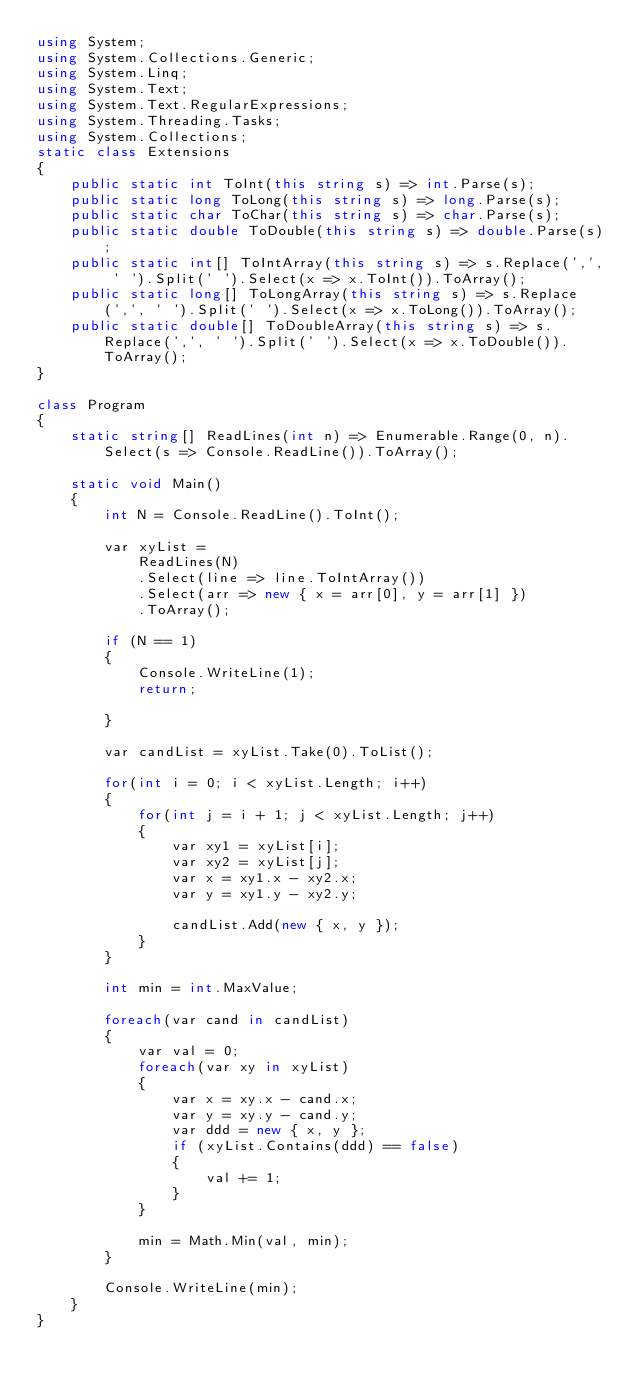Convert code to text. <code><loc_0><loc_0><loc_500><loc_500><_C#_>using System;
using System.Collections.Generic;
using System.Linq;
using System.Text;
using System.Text.RegularExpressions;
using System.Threading.Tasks;
using System.Collections;
static class Extensions
{
    public static int ToInt(this string s) => int.Parse(s);
    public static long ToLong(this string s) => long.Parse(s);
    public static char ToChar(this string s) => char.Parse(s);
    public static double ToDouble(this string s) => double.Parse(s);
    public static int[] ToIntArray(this string s) => s.Replace(',', ' ').Split(' ').Select(x => x.ToInt()).ToArray();
    public static long[] ToLongArray(this string s) => s.Replace(',', ' ').Split(' ').Select(x => x.ToLong()).ToArray();
    public static double[] ToDoubleArray(this string s) => s.Replace(',', ' ').Split(' ').Select(x => x.ToDouble()).ToArray();
}

class Program
{
    static string[] ReadLines(int n) => Enumerable.Range(0, n).Select(s => Console.ReadLine()).ToArray();

    static void Main()
    {
        int N = Console.ReadLine().ToInt();

        var xyList =
            ReadLines(N)
            .Select(line => line.ToIntArray())
            .Select(arr => new { x = arr[0], y = arr[1] })
            .ToArray();

        if (N == 1)
        {
            Console.WriteLine(1);
            return;

        }

        var candList = xyList.Take(0).ToList();

        for(int i = 0; i < xyList.Length; i++)
        {
            for(int j = i + 1; j < xyList.Length; j++)
            {
                var xy1 = xyList[i];
                var xy2 = xyList[j];
                var x = xy1.x - xy2.x;
                var y = xy1.y - xy2.y;

                candList.Add(new { x, y });
            }
        }

        int min = int.MaxValue;

        foreach(var cand in candList)
        {
            var val = 0;
            foreach(var xy in xyList)
            {
                var x = xy.x - cand.x;
                var y = xy.y - cand.y;
                var ddd = new { x, y };
                if (xyList.Contains(ddd) == false)
                {
                    val += 1;
                }
            }

            min = Math.Min(val, min);
        }

        Console.WriteLine(min);
    }
}</code> 